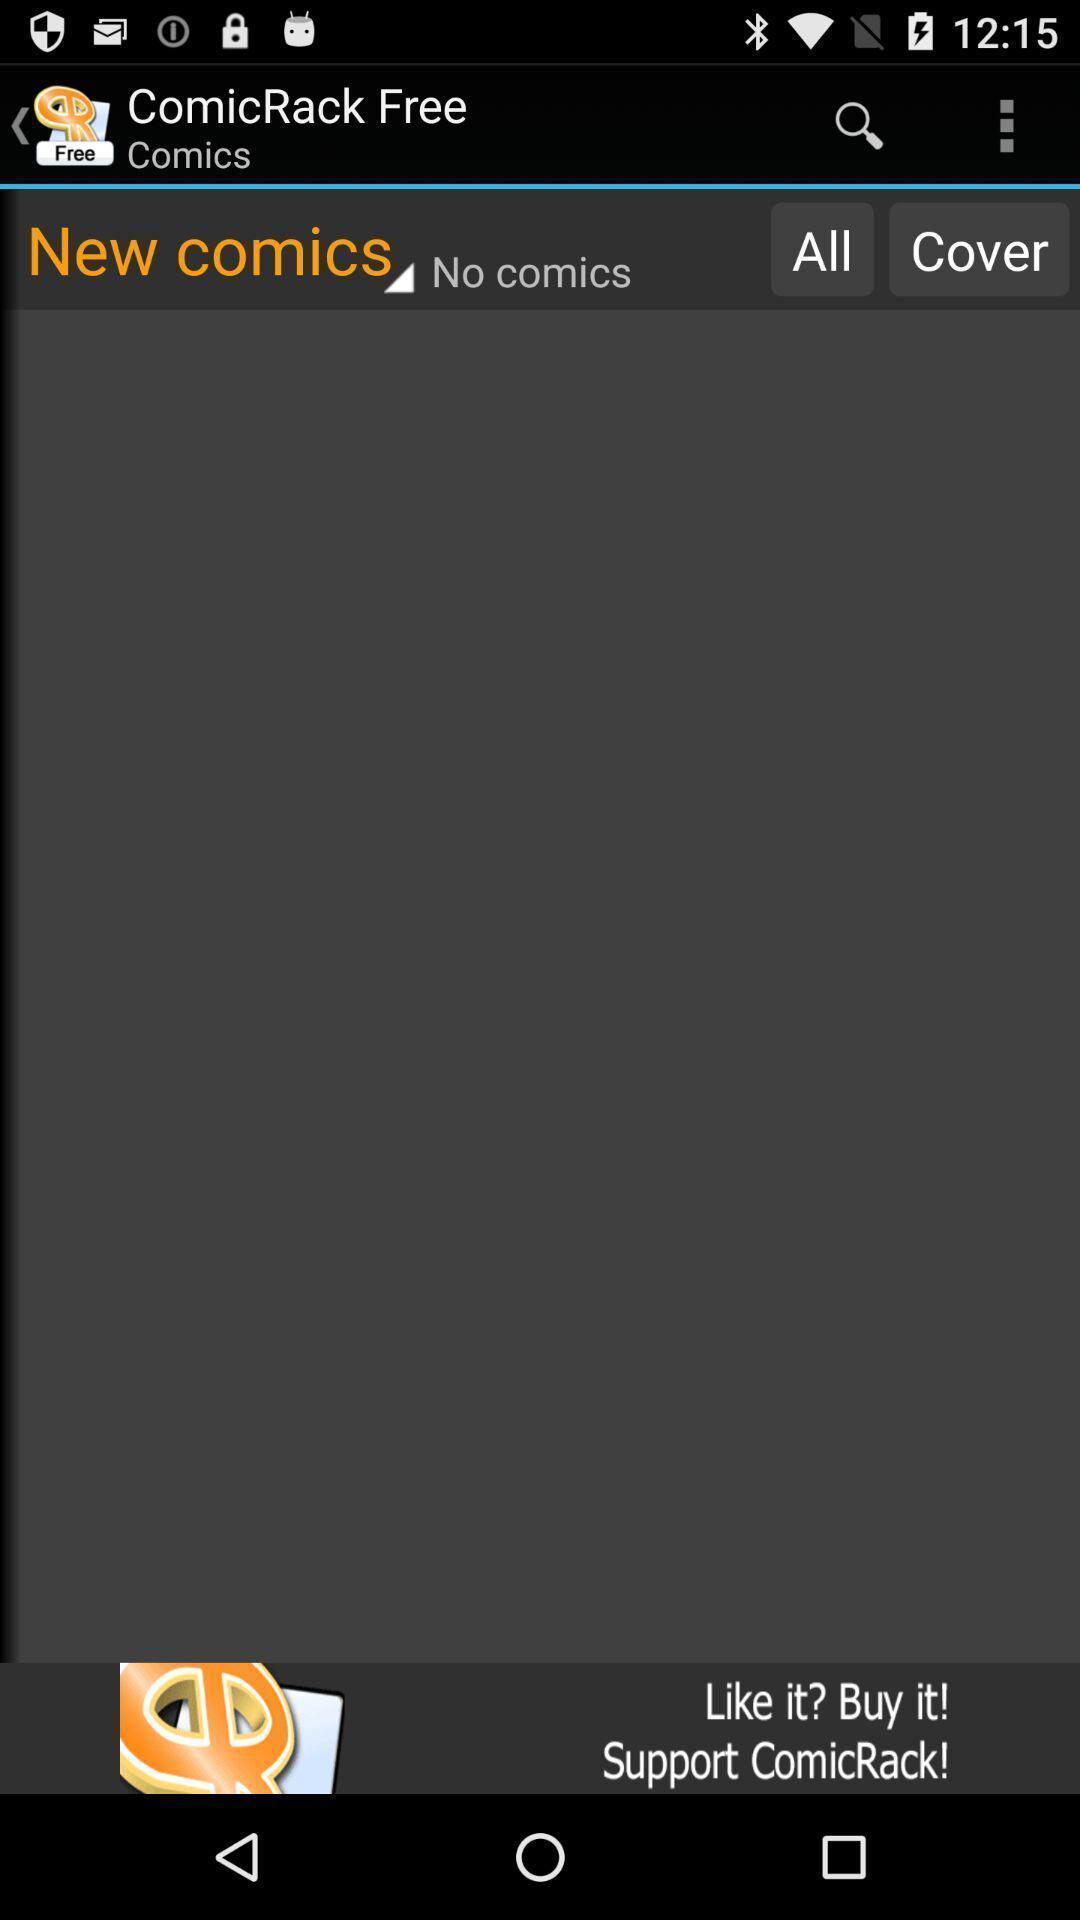Tell me about the visual elements in this screen capture. Screen showing a blank screen in comic page. 